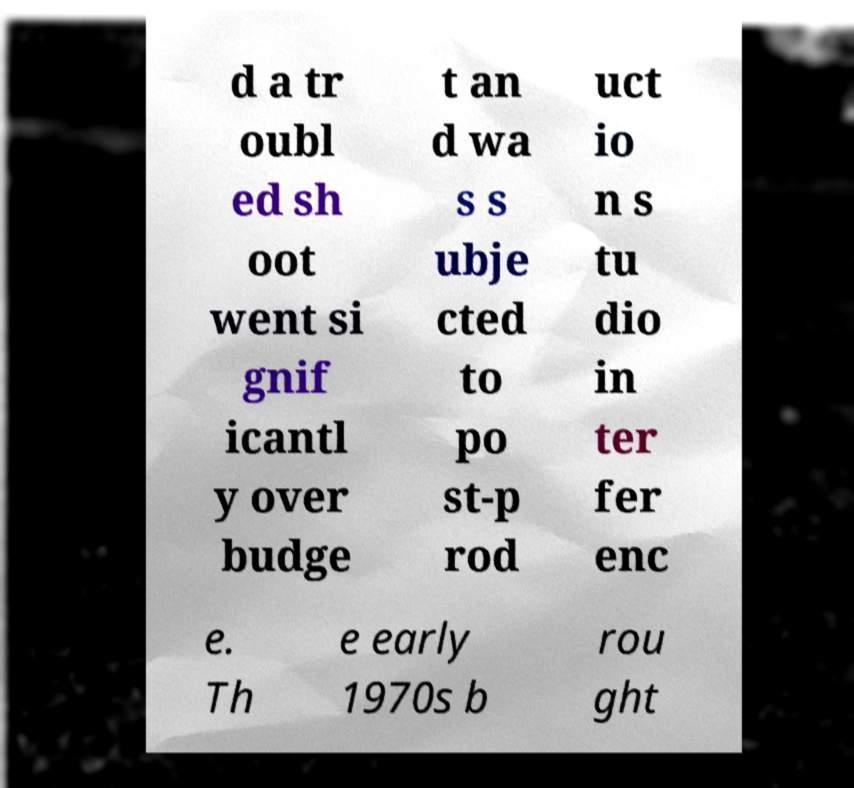Please identify and transcribe the text found in this image. d a tr oubl ed sh oot went si gnif icantl y over budge t an d wa s s ubje cted to po st-p rod uct io n s tu dio in ter fer enc e. Th e early 1970s b rou ght 